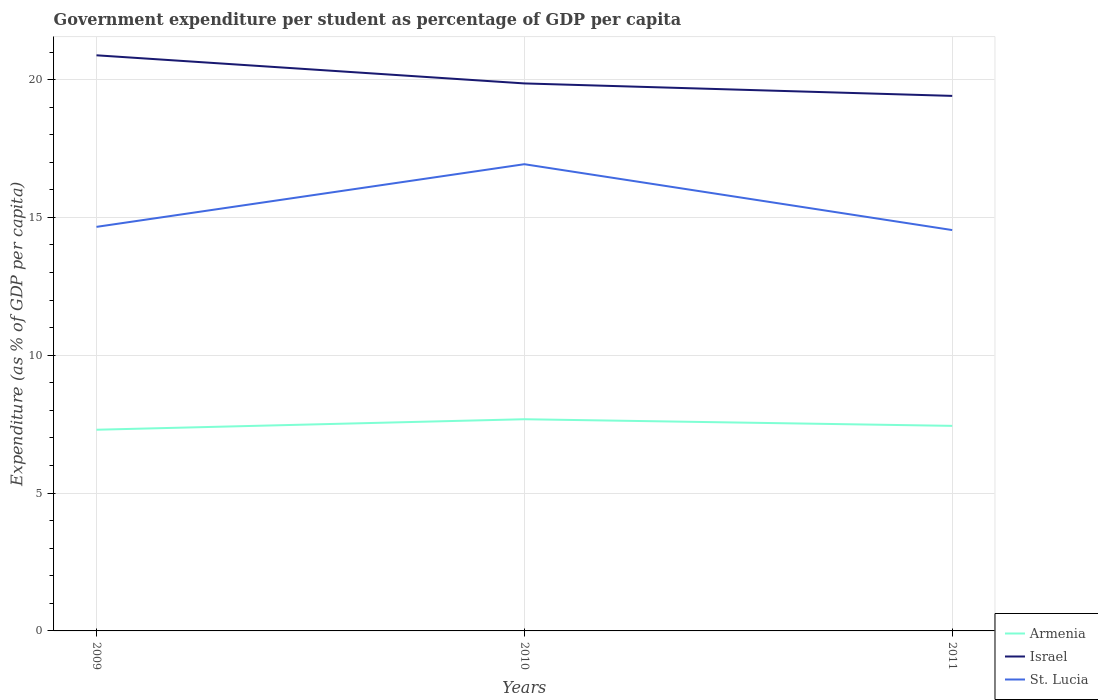Does the line corresponding to Armenia intersect with the line corresponding to Israel?
Keep it short and to the point. No. Across all years, what is the maximum percentage of expenditure per student in Armenia?
Your response must be concise. 7.3. What is the total percentage of expenditure per student in St. Lucia in the graph?
Provide a succinct answer. -2.27. What is the difference between the highest and the second highest percentage of expenditure per student in Armenia?
Offer a very short reply. 0.38. How many lines are there?
Your answer should be compact. 3. How many years are there in the graph?
Give a very brief answer. 3. Where does the legend appear in the graph?
Ensure brevity in your answer.  Bottom right. How are the legend labels stacked?
Offer a very short reply. Vertical. What is the title of the graph?
Provide a short and direct response. Government expenditure per student as percentage of GDP per capita. What is the label or title of the Y-axis?
Give a very brief answer. Expenditure (as % of GDP per capita). What is the Expenditure (as % of GDP per capita) of Armenia in 2009?
Give a very brief answer. 7.3. What is the Expenditure (as % of GDP per capita) of Israel in 2009?
Your answer should be very brief. 20.88. What is the Expenditure (as % of GDP per capita) in St. Lucia in 2009?
Give a very brief answer. 14.66. What is the Expenditure (as % of GDP per capita) of Armenia in 2010?
Give a very brief answer. 7.68. What is the Expenditure (as % of GDP per capita) of Israel in 2010?
Provide a short and direct response. 19.86. What is the Expenditure (as % of GDP per capita) of St. Lucia in 2010?
Offer a terse response. 16.93. What is the Expenditure (as % of GDP per capita) of Armenia in 2011?
Make the answer very short. 7.44. What is the Expenditure (as % of GDP per capita) of Israel in 2011?
Keep it short and to the point. 19.41. What is the Expenditure (as % of GDP per capita) in St. Lucia in 2011?
Provide a short and direct response. 14.54. Across all years, what is the maximum Expenditure (as % of GDP per capita) of Armenia?
Your answer should be very brief. 7.68. Across all years, what is the maximum Expenditure (as % of GDP per capita) in Israel?
Provide a succinct answer. 20.88. Across all years, what is the maximum Expenditure (as % of GDP per capita) in St. Lucia?
Keep it short and to the point. 16.93. Across all years, what is the minimum Expenditure (as % of GDP per capita) of Armenia?
Provide a succinct answer. 7.3. Across all years, what is the minimum Expenditure (as % of GDP per capita) of Israel?
Ensure brevity in your answer.  19.41. Across all years, what is the minimum Expenditure (as % of GDP per capita) of St. Lucia?
Give a very brief answer. 14.54. What is the total Expenditure (as % of GDP per capita) of Armenia in the graph?
Offer a terse response. 22.42. What is the total Expenditure (as % of GDP per capita) of Israel in the graph?
Give a very brief answer. 60.15. What is the total Expenditure (as % of GDP per capita) of St. Lucia in the graph?
Make the answer very short. 46.13. What is the difference between the Expenditure (as % of GDP per capita) in Armenia in 2009 and that in 2010?
Offer a very short reply. -0.38. What is the difference between the Expenditure (as % of GDP per capita) in Israel in 2009 and that in 2010?
Your response must be concise. 1.02. What is the difference between the Expenditure (as % of GDP per capita) of St. Lucia in 2009 and that in 2010?
Your answer should be very brief. -2.27. What is the difference between the Expenditure (as % of GDP per capita) of Armenia in 2009 and that in 2011?
Keep it short and to the point. -0.14. What is the difference between the Expenditure (as % of GDP per capita) in Israel in 2009 and that in 2011?
Your response must be concise. 1.47. What is the difference between the Expenditure (as % of GDP per capita) in St. Lucia in 2009 and that in 2011?
Your response must be concise. 0.12. What is the difference between the Expenditure (as % of GDP per capita) of Armenia in 2010 and that in 2011?
Provide a succinct answer. 0.24. What is the difference between the Expenditure (as % of GDP per capita) in Israel in 2010 and that in 2011?
Your response must be concise. 0.45. What is the difference between the Expenditure (as % of GDP per capita) of St. Lucia in 2010 and that in 2011?
Make the answer very short. 2.39. What is the difference between the Expenditure (as % of GDP per capita) in Armenia in 2009 and the Expenditure (as % of GDP per capita) in Israel in 2010?
Give a very brief answer. -12.56. What is the difference between the Expenditure (as % of GDP per capita) of Armenia in 2009 and the Expenditure (as % of GDP per capita) of St. Lucia in 2010?
Make the answer very short. -9.63. What is the difference between the Expenditure (as % of GDP per capita) of Israel in 2009 and the Expenditure (as % of GDP per capita) of St. Lucia in 2010?
Offer a very short reply. 3.95. What is the difference between the Expenditure (as % of GDP per capita) of Armenia in 2009 and the Expenditure (as % of GDP per capita) of Israel in 2011?
Your answer should be very brief. -12.11. What is the difference between the Expenditure (as % of GDP per capita) of Armenia in 2009 and the Expenditure (as % of GDP per capita) of St. Lucia in 2011?
Make the answer very short. -7.24. What is the difference between the Expenditure (as % of GDP per capita) of Israel in 2009 and the Expenditure (as % of GDP per capita) of St. Lucia in 2011?
Your answer should be compact. 6.34. What is the difference between the Expenditure (as % of GDP per capita) of Armenia in 2010 and the Expenditure (as % of GDP per capita) of Israel in 2011?
Offer a very short reply. -11.73. What is the difference between the Expenditure (as % of GDP per capita) in Armenia in 2010 and the Expenditure (as % of GDP per capita) in St. Lucia in 2011?
Provide a short and direct response. -6.86. What is the difference between the Expenditure (as % of GDP per capita) of Israel in 2010 and the Expenditure (as % of GDP per capita) of St. Lucia in 2011?
Keep it short and to the point. 5.32. What is the average Expenditure (as % of GDP per capita) of Armenia per year?
Offer a terse response. 7.47. What is the average Expenditure (as % of GDP per capita) of Israel per year?
Your response must be concise. 20.05. What is the average Expenditure (as % of GDP per capita) of St. Lucia per year?
Keep it short and to the point. 15.38. In the year 2009, what is the difference between the Expenditure (as % of GDP per capita) in Armenia and Expenditure (as % of GDP per capita) in Israel?
Offer a very short reply. -13.58. In the year 2009, what is the difference between the Expenditure (as % of GDP per capita) in Armenia and Expenditure (as % of GDP per capita) in St. Lucia?
Provide a short and direct response. -7.36. In the year 2009, what is the difference between the Expenditure (as % of GDP per capita) of Israel and Expenditure (as % of GDP per capita) of St. Lucia?
Offer a very short reply. 6.22. In the year 2010, what is the difference between the Expenditure (as % of GDP per capita) in Armenia and Expenditure (as % of GDP per capita) in Israel?
Your answer should be compact. -12.18. In the year 2010, what is the difference between the Expenditure (as % of GDP per capita) in Armenia and Expenditure (as % of GDP per capita) in St. Lucia?
Give a very brief answer. -9.25. In the year 2010, what is the difference between the Expenditure (as % of GDP per capita) in Israel and Expenditure (as % of GDP per capita) in St. Lucia?
Ensure brevity in your answer.  2.93. In the year 2011, what is the difference between the Expenditure (as % of GDP per capita) in Armenia and Expenditure (as % of GDP per capita) in Israel?
Offer a very short reply. -11.97. In the year 2011, what is the difference between the Expenditure (as % of GDP per capita) in Armenia and Expenditure (as % of GDP per capita) in St. Lucia?
Provide a short and direct response. -7.1. In the year 2011, what is the difference between the Expenditure (as % of GDP per capita) of Israel and Expenditure (as % of GDP per capita) of St. Lucia?
Ensure brevity in your answer.  4.87. What is the ratio of the Expenditure (as % of GDP per capita) in Armenia in 2009 to that in 2010?
Your answer should be compact. 0.95. What is the ratio of the Expenditure (as % of GDP per capita) of Israel in 2009 to that in 2010?
Keep it short and to the point. 1.05. What is the ratio of the Expenditure (as % of GDP per capita) of St. Lucia in 2009 to that in 2010?
Offer a terse response. 0.87. What is the ratio of the Expenditure (as % of GDP per capita) of Armenia in 2009 to that in 2011?
Make the answer very short. 0.98. What is the ratio of the Expenditure (as % of GDP per capita) of Israel in 2009 to that in 2011?
Your answer should be very brief. 1.08. What is the ratio of the Expenditure (as % of GDP per capita) of St. Lucia in 2009 to that in 2011?
Keep it short and to the point. 1.01. What is the ratio of the Expenditure (as % of GDP per capita) of Armenia in 2010 to that in 2011?
Offer a terse response. 1.03. What is the ratio of the Expenditure (as % of GDP per capita) of Israel in 2010 to that in 2011?
Keep it short and to the point. 1.02. What is the ratio of the Expenditure (as % of GDP per capita) in St. Lucia in 2010 to that in 2011?
Give a very brief answer. 1.16. What is the difference between the highest and the second highest Expenditure (as % of GDP per capita) of Armenia?
Provide a succinct answer. 0.24. What is the difference between the highest and the second highest Expenditure (as % of GDP per capita) in Israel?
Keep it short and to the point. 1.02. What is the difference between the highest and the second highest Expenditure (as % of GDP per capita) of St. Lucia?
Provide a short and direct response. 2.27. What is the difference between the highest and the lowest Expenditure (as % of GDP per capita) of Armenia?
Your response must be concise. 0.38. What is the difference between the highest and the lowest Expenditure (as % of GDP per capita) of Israel?
Keep it short and to the point. 1.47. What is the difference between the highest and the lowest Expenditure (as % of GDP per capita) of St. Lucia?
Your answer should be compact. 2.39. 